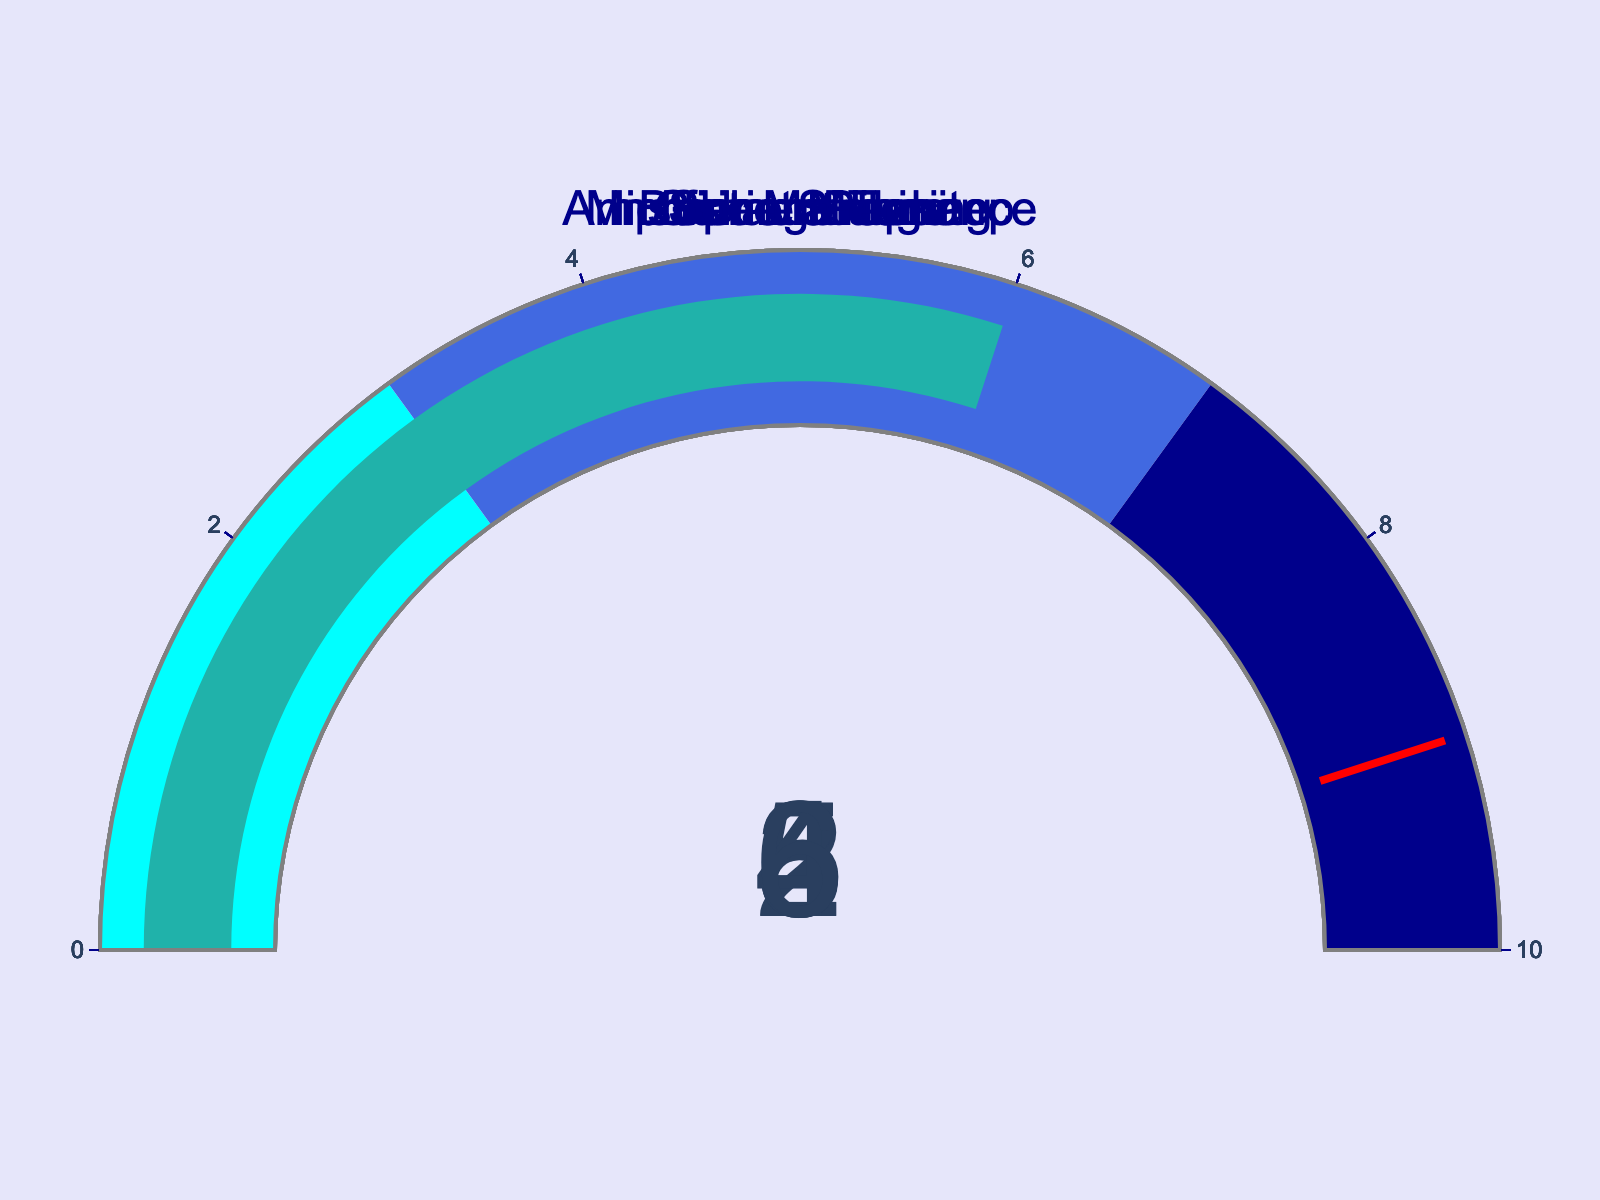What's the percentage spent on Guitar Strings? The gauge for Guitar Strings shows the percentage of monthly income spent on these. Simply read the value indicated on the gauge.
Answer: 5 What's the sum of percentages spent on Instrument Tuning and Sheet Music? Add the percentage values indicated on the gauges for Instrument Tuning and Sheet Music. Instrument Tuning is 2 and Sheet Music is 3, so 2 + 3 = 5.
Answer: 5 Which expense category has the highest percentage? Compare all the numbers displayed on each of the gauges and identify the highest value. The expenses are: Guitar Strings (5), Instrument Tuning (2), Amplifier Maintenance (8), Sheet Music (3), Busking Permit (4), Microphone Upkeep (6). The highest value is for Amplifier Maintenance.
Answer: Amplifier Maintenance How much more is spent on Microphone Upkeep than Busking Permit in percentage? Subtract the percentage value for Busking Permit from that of Microphone Upkeep. Microphone Upkeep is 6, Busking Permit is 4. 6 - 4 = 2.
Answer: 2 What's the average percentage spent on all the expenses? Sum the percentage values for all expenses and divide by the total number of expenses. Values: 5, 2, 8, 3, 4, 6. Sum = 5 + 2 + 8 + 3 + 4 + 6 = 28. Number of expenses = 6. Average = 28 / 6 = 4.67.
Answer: 4.67 Which expenses have values above 5%? Identify all the gauges where the displayed percentage value is greater than 5. These are Amplifier Maintenance (8) and Microphone Upkeep (6).
Answer: Amplifier Maintenance, Microphone Upkeep What's the total percentage of income spent on expenses related to equipment (excluding maintenance and permits)? Sum the percentage values for expenses that are strictly equipment-related. Guitar Strings is 5 and Sheet Music is 3. 5 + 3 = 8.
Answer: 8 By how much does the percentage spent on Guitar Strings exceed that of Busking Permit? Subtract the percentage for Busking Permit from Guitar Strings. Guitar Strings is 5, Busking Permit is 4. 5 - 4 = 1.
Answer: 1 